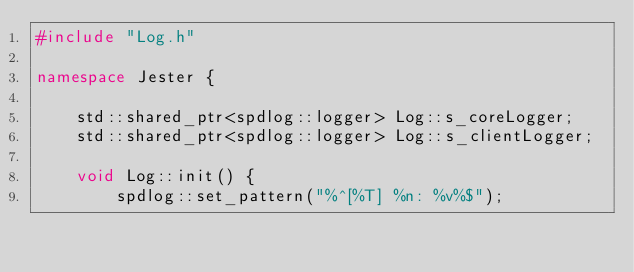<code> <loc_0><loc_0><loc_500><loc_500><_C++_>#include "Log.h"

namespace Jester {

	std::shared_ptr<spdlog::logger> Log::s_coreLogger;
	std::shared_ptr<spdlog::logger> Log::s_clientLogger;
	
	void Log::init() {
		spdlog::set_pattern("%^[%T] %n: %v%$");</code> 